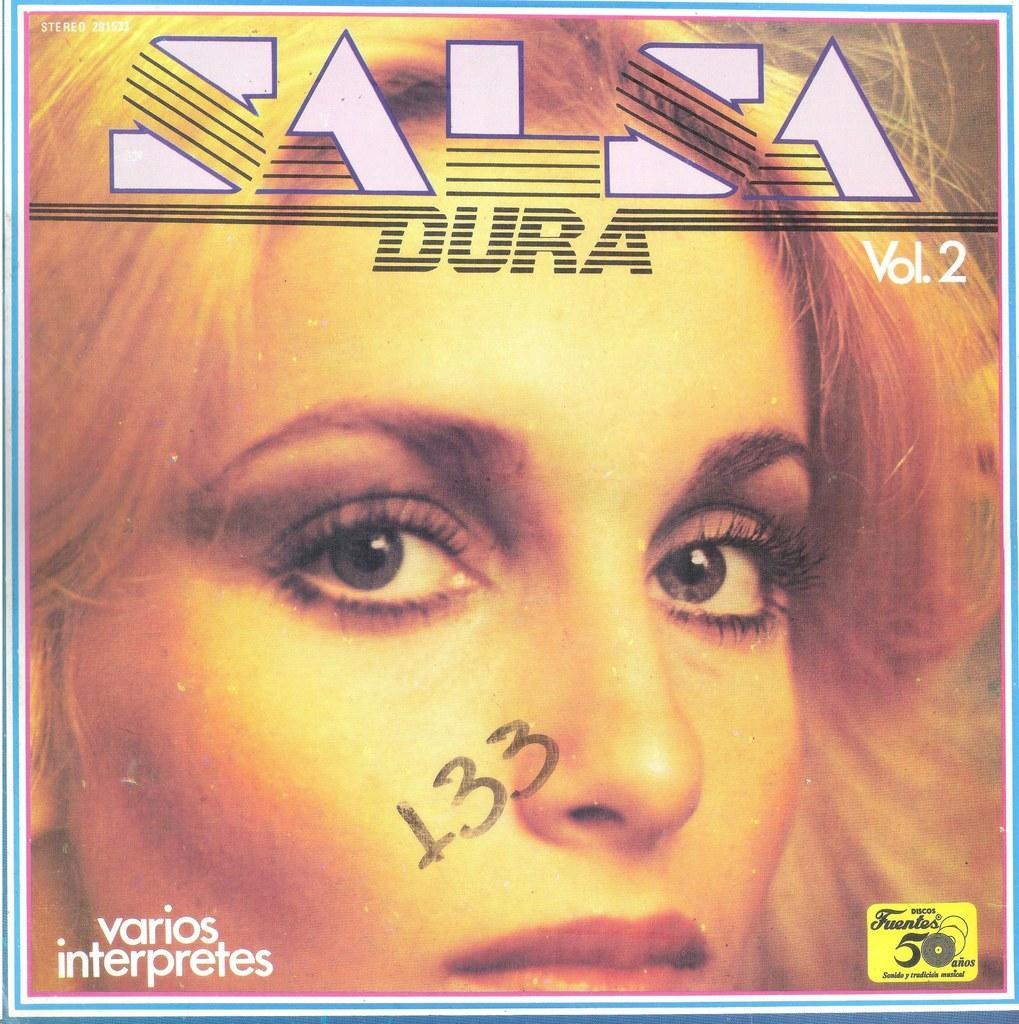<image>
Create a compact narrative representing the image presented. a cd that has the title 'salsa dura vol.2' on it 